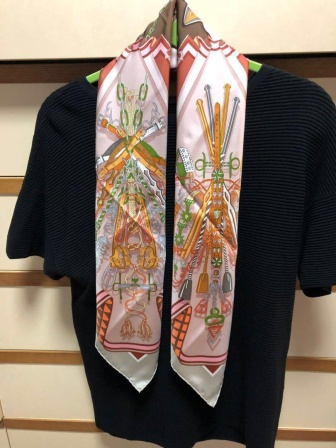What's the main purpose of this setup? The main purpose of this setup is likely to display clothing items in an appealing and stylish manner. The black sweater serves as a neutral yet elegant base, while the colorful scarf adds a touch of personality and flair. This arrangement might be used in a retail store to attract customers by showcasing how the two items can be paired together, or it could be a part of a home decor to create a cozy and fashionable look. 